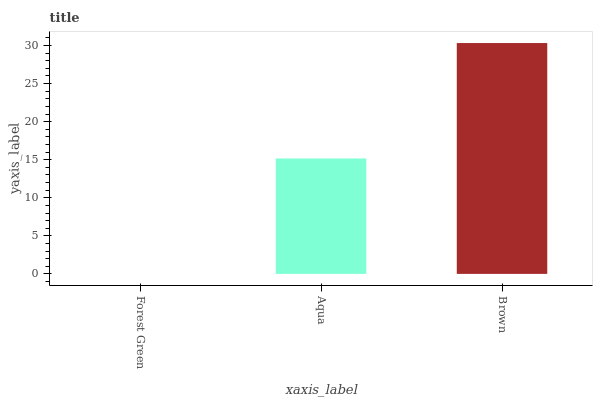Is Forest Green the minimum?
Answer yes or no. Yes. Is Brown the maximum?
Answer yes or no. Yes. Is Aqua the minimum?
Answer yes or no. No. Is Aqua the maximum?
Answer yes or no. No. Is Aqua greater than Forest Green?
Answer yes or no. Yes. Is Forest Green less than Aqua?
Answer yes or no. Yes. Is Forest Green greater than Aqua?
Answer yes or no. No. Is Aqua less than Forest Green?
Answer yes or no. No. Is Aqua the high median?
Answer yes or no. Yes. Is Aqua the low median?
Answer yes or no. Yes. Is Brown the high median?
Answer yes or no. No. Is Brown the low median?
Answer yes or no. No. 